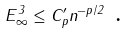Convert formula to latex. <formula><loc_0><loc_0><loc_500><loc_500>E _ { \infty } ^ { 3 } \leq C ^ { \prime } _ { p } n ^ { - p / 2 } \text { .}</formula> 